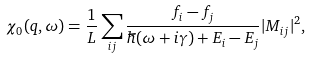<formula> <loc_0><loc_0><loc_500><loc_500>\chi _ { 0 } ( q , \omega ) = \frac { 1 } { L } \sum _ { i j } \frac { f _ { i } - f _ { j } } { \hbar { ( } \omega + i \gamma ) + E _ { i } - E _ { j } } | M _ { i j } | ^ { 2 } ,</formula> 